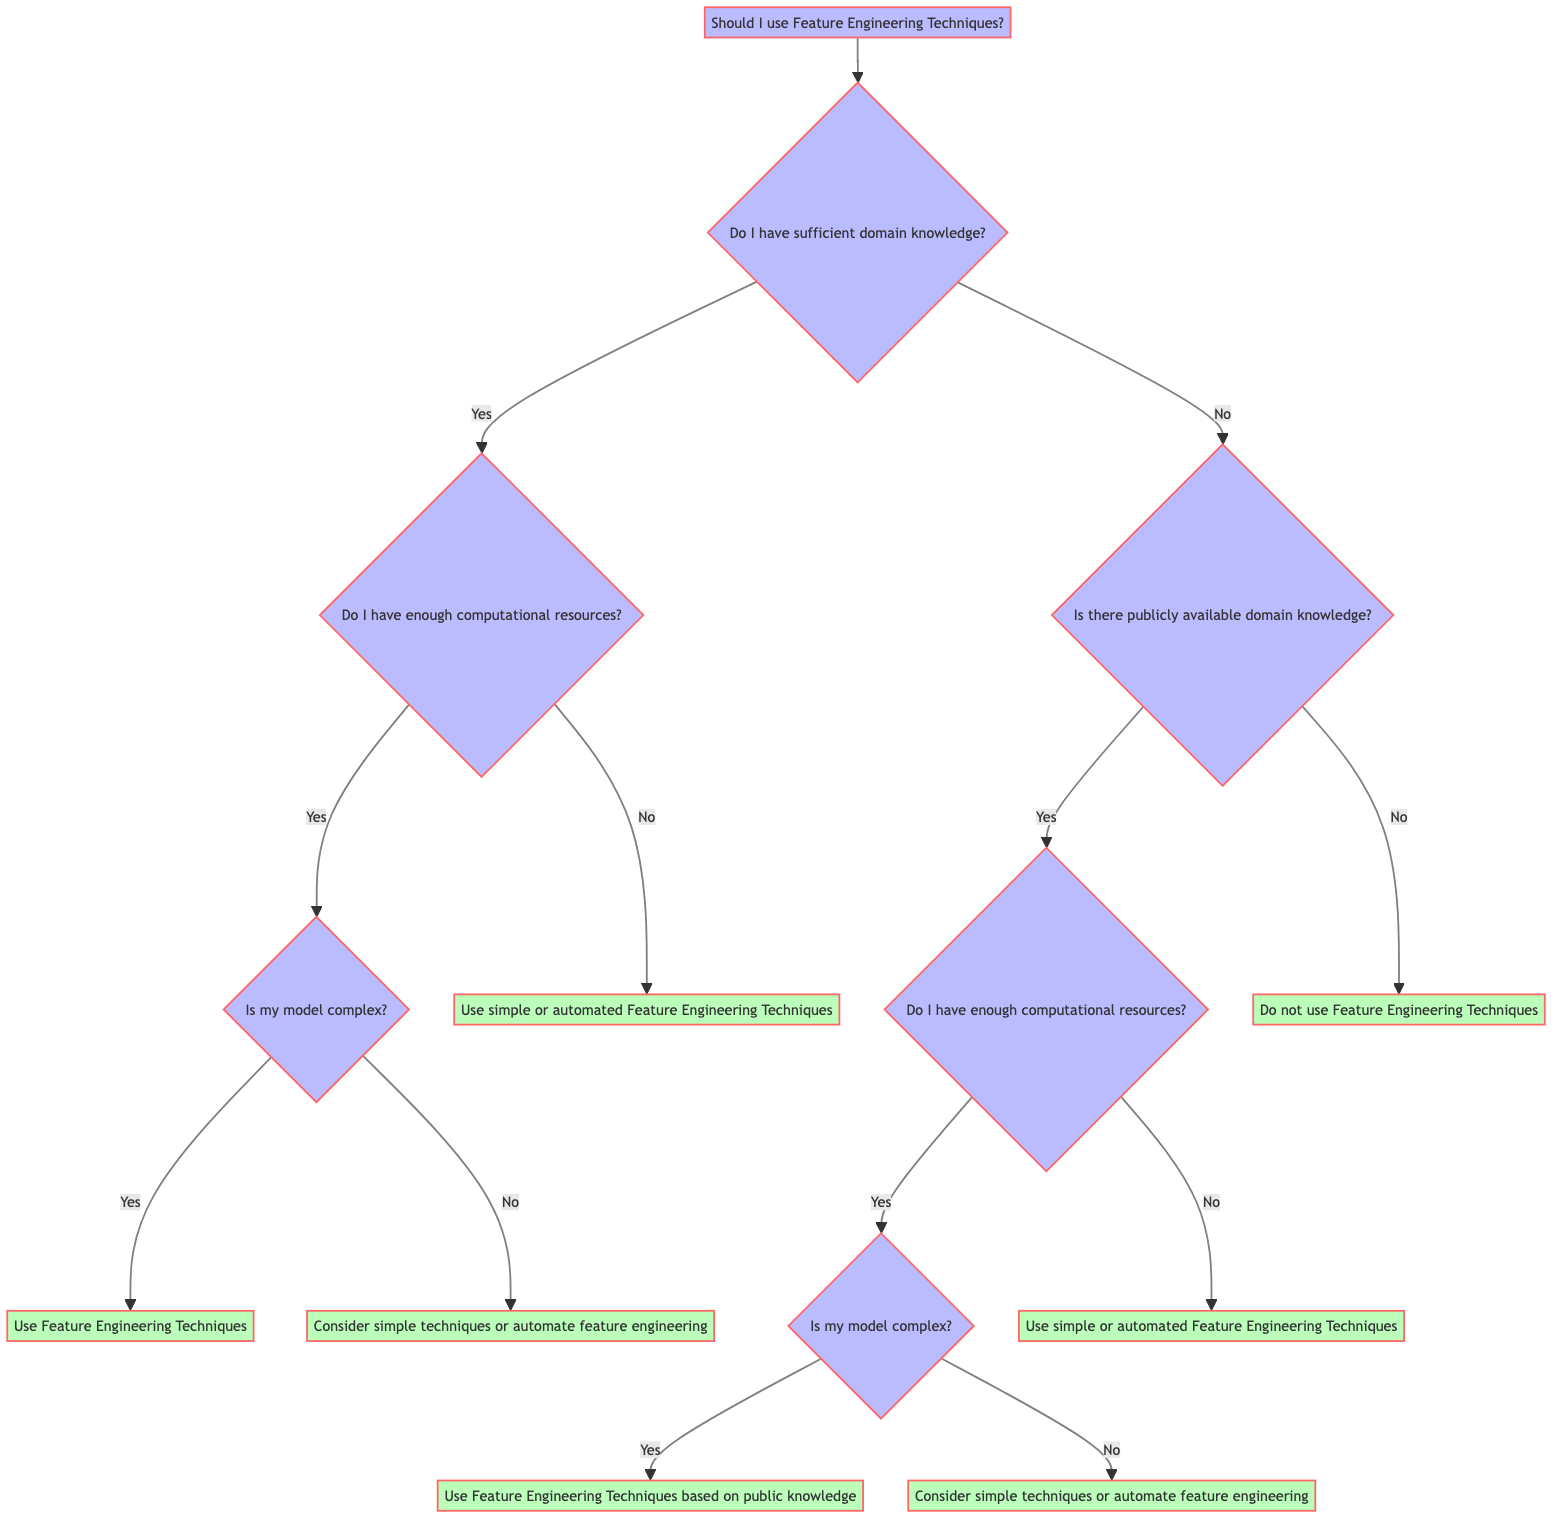What is the first decision point in the diagram? The first decision point is whether there is sufficient domain knowledge.
Answer: sufficient domain knowledge How many terminal nodes are there in the diagram? The terminal nodes are labeled with the actions and are located at the bottom of the diagram: Use Feature Engineering Techniques, Consider simple techniques or automate feature engineering, Use simple or automated Feature Engineering Techniques, and Do not use Feature Engineering Techniques. There are four terminal nodes.
Answer: four What happens if there is no sufficient domain knowledge? If there is no sufficient domain knowledge, the diagram leads to the next question, "Is there publicly available domain knowledge?"
Answer: Is there publicly available domain knowledge? What is the action taken when both domain knowledge and computational resources are sufficient, but the model is not complex? The action taken is to consider simple techniques or automate feature engineering.
Answer: Consider simple techniques or automate feature engineering If there is publicly available domain knowledge but insufficient computational resources, what should be done? The diagram states that in this case, one should not use Feature Engineering Techniques.
Answer: Do not use Feature Engineering Techniques If both domain knowledge and computational resources are present, and the model is complex, what should be done? The action specified is to use Feature Engineering Techniques.
Answer: Use Feature Engineering Techniques What is the relationship between having sufficient computational resources and the action to be taken? The relationship is conditional; having sufficient computational resources determines whether to assess the complexity of the model and decide the corresponding action based on that.
Answer: conditional relationship What would lead to using Feature Engineering Techniques based on public knowledge? This occurs when there is publicly available domain knowledge, sufficient computational resources, and a complex model.
Answer: Use Feature Engineering Techniques based on public knowledge What action is recommended if neither sufficient domain knowledge nor publicly available domain knowledge is present? The diagram suggests that the action should be to not use Feature Engineering Techniques.
Answer: Do not use Feature Engineering Techniques 